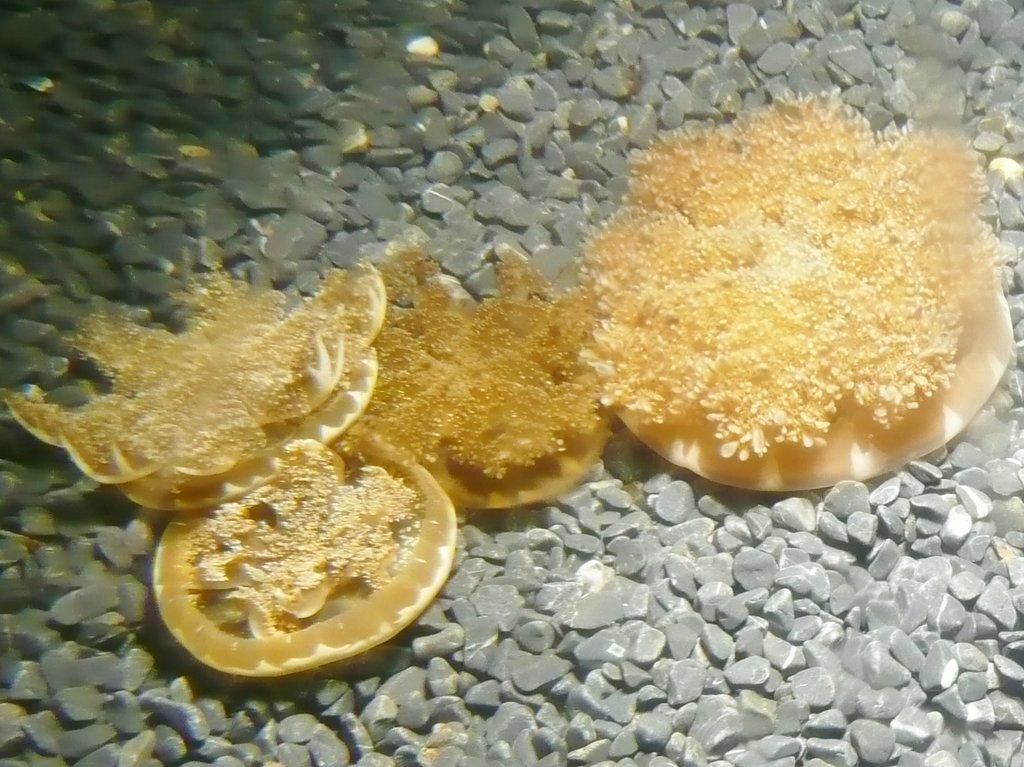What type of plants are in the center of the image? There are water plants in the center of the image. What else can be seen in the center of the image besides the water plants? There are stones in the center of the image. What type of band is playing in the background of the image? There is no band present in the image. 